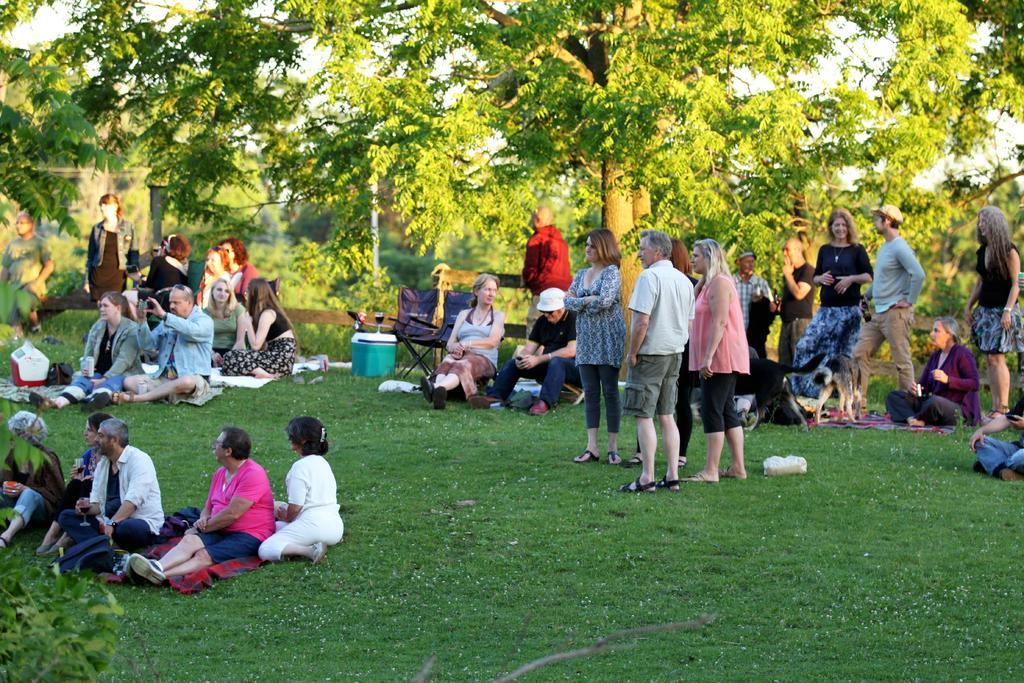Could you give a brief overview of what you see in this image? In this picture I can see there are a group of people here, few of them are standing and few of them are sitting on the floor. There are trees in the backdrop. 